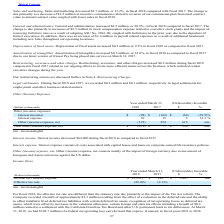According to Agilysys's financial document, What was the decrease in interest income in fiscal 2018? According to the financial document, $64,000. The relevant text states: "Interest income. Interest income decreased $64,000 during fiscal 2018 as compared to fiscal 2017...." Also, What are the interest expense comprised of? costs associated with capital leases and loans on corporate-owned life insurance policies.. The document states: "Interest expense. Interest expense consists of costs associated with capital leases and loans on corporate-owned life insurance policies...." Also, What is the interest income in 2018? According to the financial document, $(98) (in thousands). The relevant text states: "Interest (income) $ (98) $ (162) $ (64) (39.5)%..." Also, can you calculate: What is  Interest (income) expressed as a percentage of  Total other (income) expense, net? To answer this question, I need to perform calculations using the financial data. The calculation is: -98/-479, which equals 20.46 (percentage). This is based on the information: "Total other (income) expense, net $ (479) $ 77 $ 556 nm Interest (income) $ (98) $ (162) $ (64) (39.5)%..." The key data points involved are: 479, 98. Also, can you calculate: What is the average interest expense for 2017 and 2018? To answer this question, I need to perform calculations using the financial data. The calculation is: (10 + 15) / 2, which equals 12.5 (in thousands). This is based on the information: "Interest expense 10 15 5 33.3 % Interest expense 10 15 5 33.3 %..." The key data points involved are: 10, 15. Also, can you calculate: What is the average Other (income) expense, net for 2017 and 2018? To answer this question, I need to perform calculations using the financial data. The calculation is: (-391 + 224) / 2, which equals -83.5 (in thousands). This is based on the information: "Other (income) expense, net (391) 224 615 nm Other (income) expense, net (391) 224 615 nm..." The key data points involved are: 224, 391. 